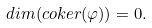Convert formula to latex. <formula><loc_0><loc_0><loc_500><loc_500>d i m ( c o k e r ( \varphi ) ) = 0 .</formula> 